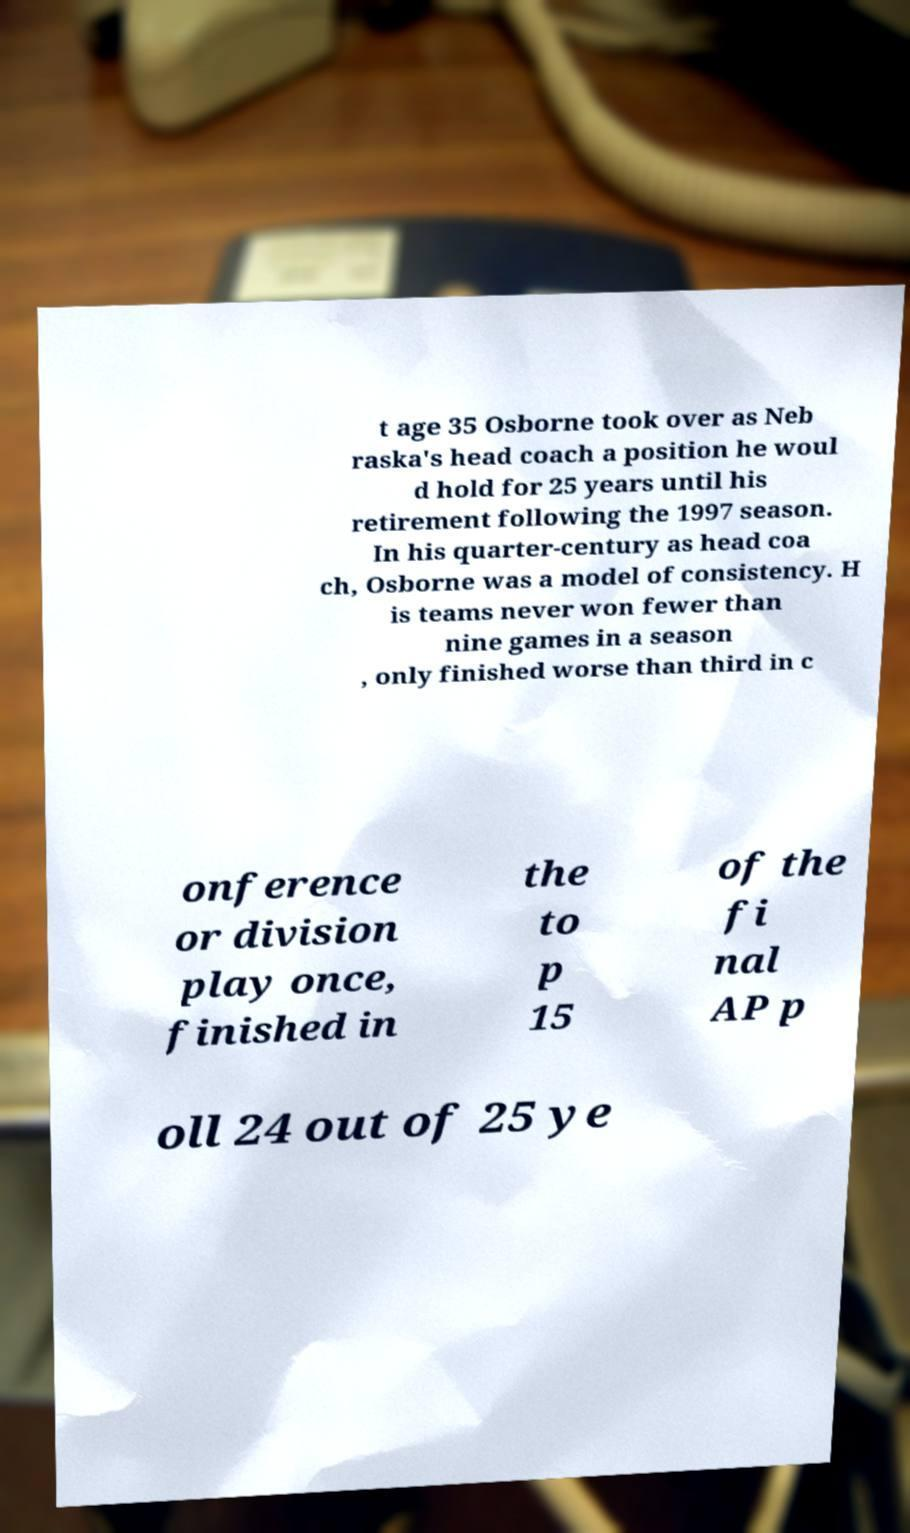For documentation purposes, I need the text within this image transcribed. Could you provide that? t age 35 Osborne took over as Neb raska's head coach a position he woul d hold for 25 years until his retirement following the 1997 season. In his quarter-century as head coa ch, Osborne was a model of consistency. H is teams never won fewer than nine games in a season , only finished worse than third in c onference or division play once, finished in the to p 15 of the fi nal AP p oll 24 out of 25 ye 